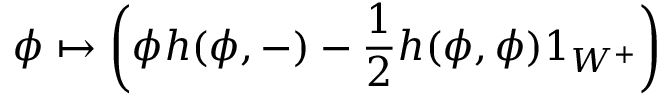Convert formula to latex. <formula><loc_0><loc_0><loc_500><loc_500>\phi \mapsto \left ( \phi h ( \phi , - ) - { \frac { 1 } { 2 } } h ( \phi , \phi ) 1 _ { W ^ { + } } \right )</formula> 